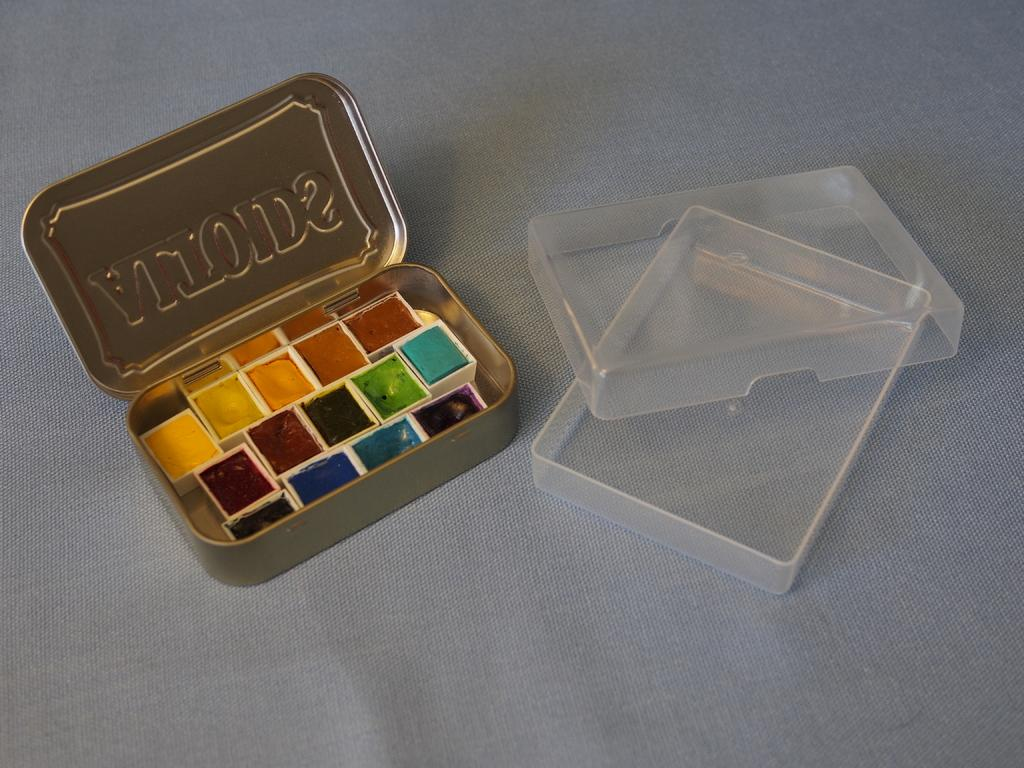<image>
Summarize the visual content of the image. Small samples of colored paints inside tiny containers in an Altoids tin. 